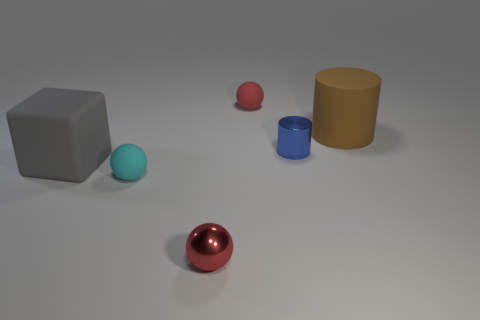Subtract all small cyan balls. How many balls are left? 2 Add 4 cylinders. How many objects exist? 10 Subtract all cyan spheres. How many spheres are left? 2 Subtract all gray cubes. How many red spheres are left? 2 Subtract all cylinders. How many objects are left? 4 Add 6 cyan spheres. How many cyan spheres exist? 7 Subtract 1 cyan spheres. How many objects are left? 5 Subtract all brown cylinders. Subtract all green spheres. How many cylinders are left? 1 Subtract all purple things. Subtract all red shiny balls. How many objects are left? 5 Add 1 big brown cylinders. How many big brown cylinders are left? 2 